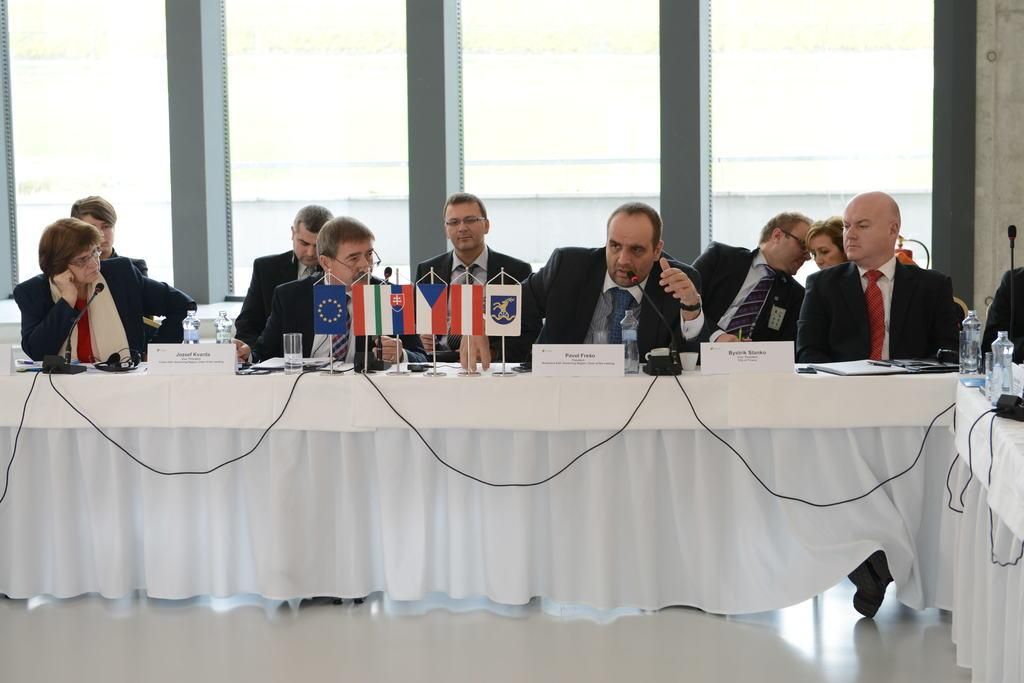What are the people in the image doing? The people in the image are sitting on chairs. What can be seen on the table in the image? There are mice, glasses, bottles, devices, and other objects on the table. What is the color of the cloth visible in the image? The cloth visible in the image is white. What type of letter is being written by the mice on the table? There are no mice writing letters in the image; the mice are simply present on the table. What kind of pets are sitting on the chairs in the image? There are no pets sitting on the chairs in the image; the people are the ones sitting on the chairs. 